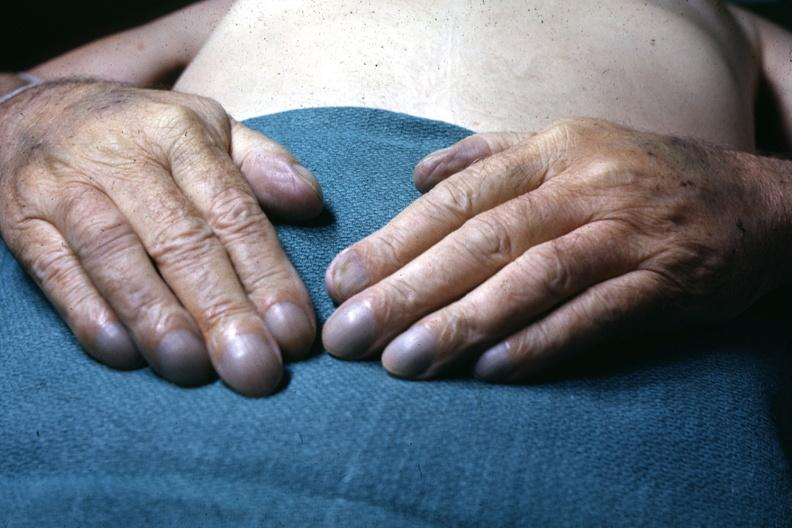what is present?
Answer the question using a single word or phrase. Hand 